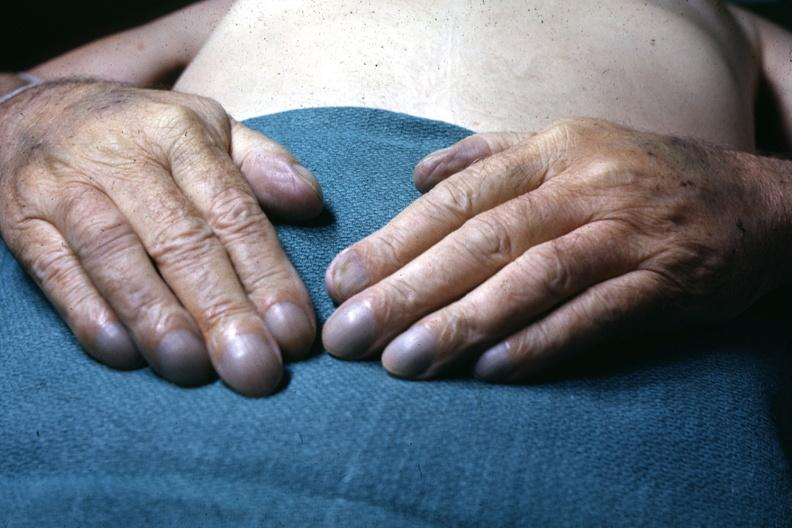what is present?
Answer the question using a single word or phrase. Hand 